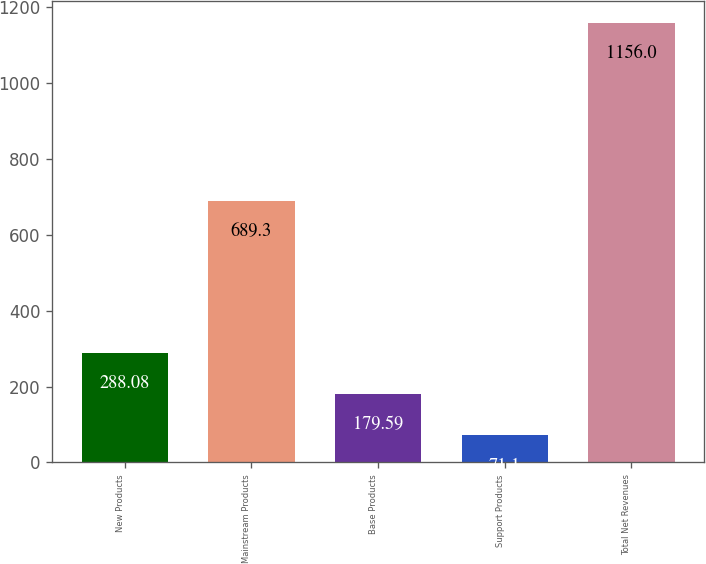<chart> <loc_0><loc_0><loc_500><loc_500><bar_chart><fcel>New Products<fcel>Mainstream Products<fcel>Base Products<fcel>Support Products<fcel>Total Net Revenues<nl><fcel>288.08<fcel>689.3<fcel>179.59<fcel>71.1<fcel>1156<nl></chart> 